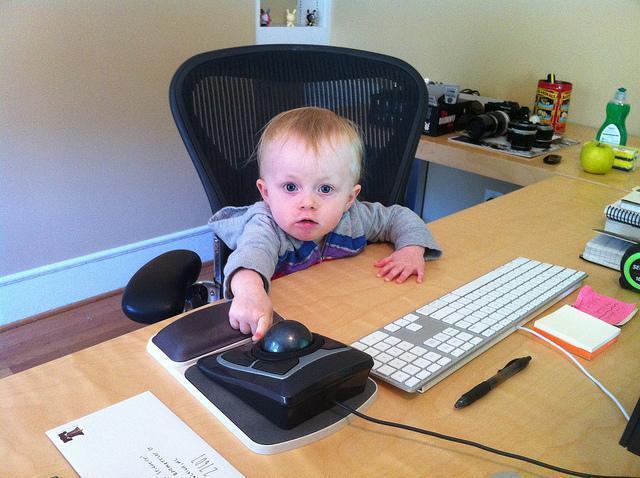How many black remotes are on the table?
Give a very brief answer. 0. 